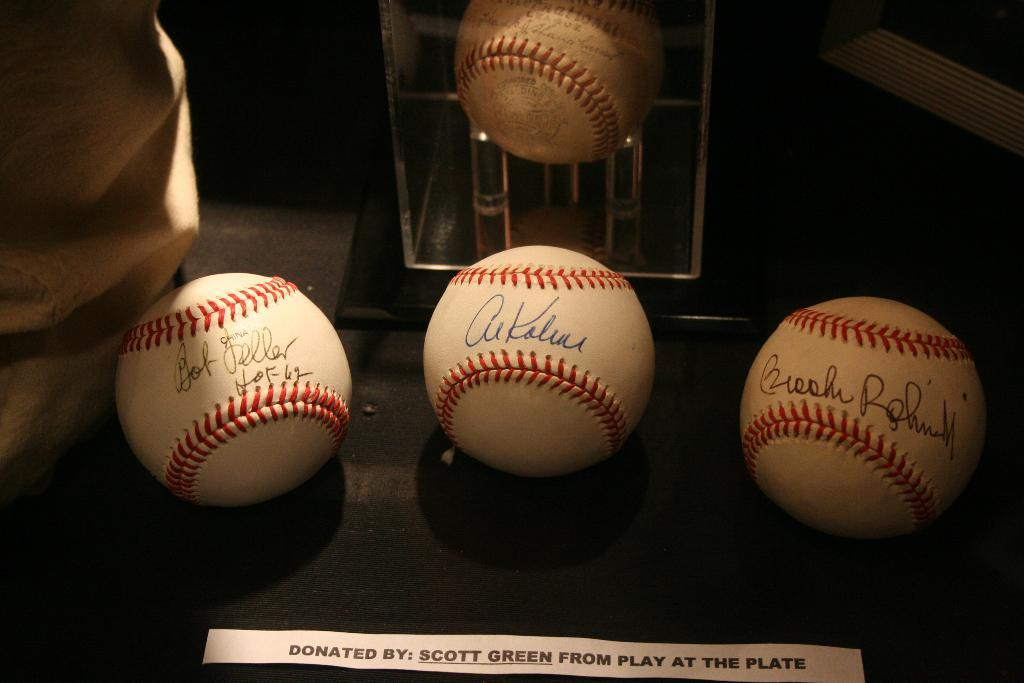<image>
Render a clear and concise summary of the photo. Baseballs on display donated by Scott Green from play at the plate. 